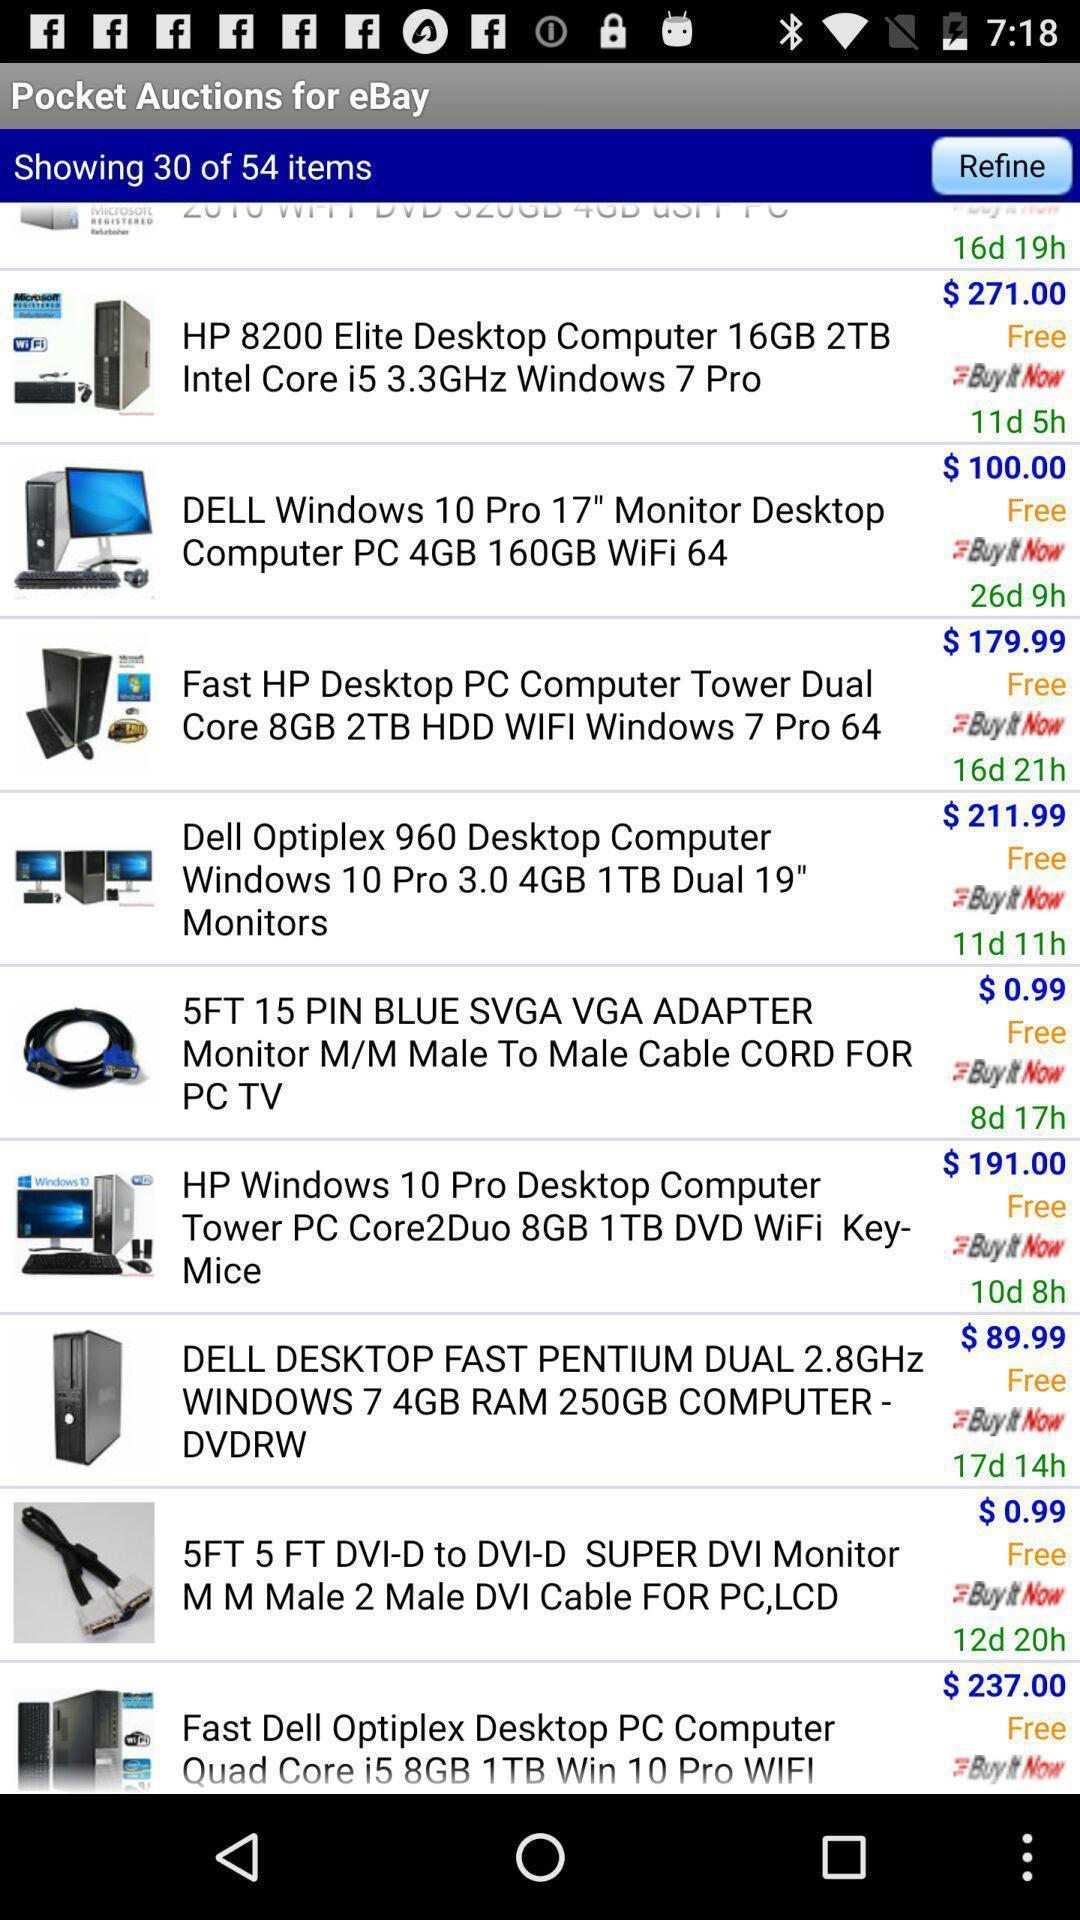Describe this image in words. Page showing list of pc items in a shopping app. 